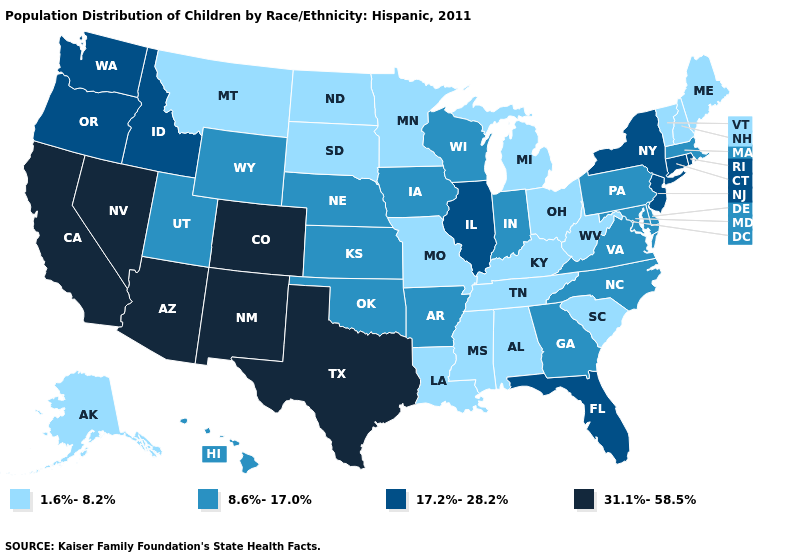What is the value of New York?
Quick response, please. 17.2%-28.2%. Does Arizona have the highest value in the West?
Answer briefly. Yes. What is the highest value in the MidWest ?
Give a very brief answer. 17.2%-28.2%. Does Hawaii have the same value as Minnesota?
Short answer required. No. Name the states that have a value in the range 8.6%-17.0%?
Quick response, please. Arkansas, Delaware, Georgia, Hawaii, Indiana, Iowa, Kansas, Maryland, Massachusetts, Nebraska, North Carolina, Oklahoma, Pennsylvania, Utah, Virginia, Wisconsin, Wyoming. What is the value of West Virginia?
Answer briefly. 1.6%-8.2%. What is the value of Montana?
Answer briefly. 1.6%-8.2%. Does the map have missing data?
Write a very short answer. No. Which states have the lowest value in the USA?
Keep it brief. Alabama, Alaska, Kentucky, Louisiana, Maine, Michigan, Minnesota, Mississippi, Missouri, Montana, New Hampshire, North Dakota, Ohio, South Carolina, South Dakota, Tennessee, Vermont, West Virginia. What is the highest value in states that border Ohio?
Keep it brief. 8.6%-17.0%. Name the states that have a value in the range 1.6%-8.2%?
Keep it brief. Alabama, Alaska, Kentucky, Louisiana, Maine, Michigan, Minnesota, Mississippi, Missouri, Montana, New Hampshire, North Dakota, Ohio, South Carolina, South Dakota, Tennessee, Vermont, West Virginia. What is the value of Rhode Island?
Answer briefly. 17.2%-28.2%. Does New York have the highest value in the USA?
Answer briefly. No. What is the value of Delaware?
Quick response, please. 8.6%-17.0%. Name the states that have a value in the range 8.6%-17.0%?
Quick response, please. Arkansas, Delaware, Georgia, Hawaii, Indiana, Iowa, Kansas, Maryland, Massachusetts, Nebraska, North Carolina, Oklahoma, Pennsylvania, Utah, Virginia, Wisconsin, Wyoming. 